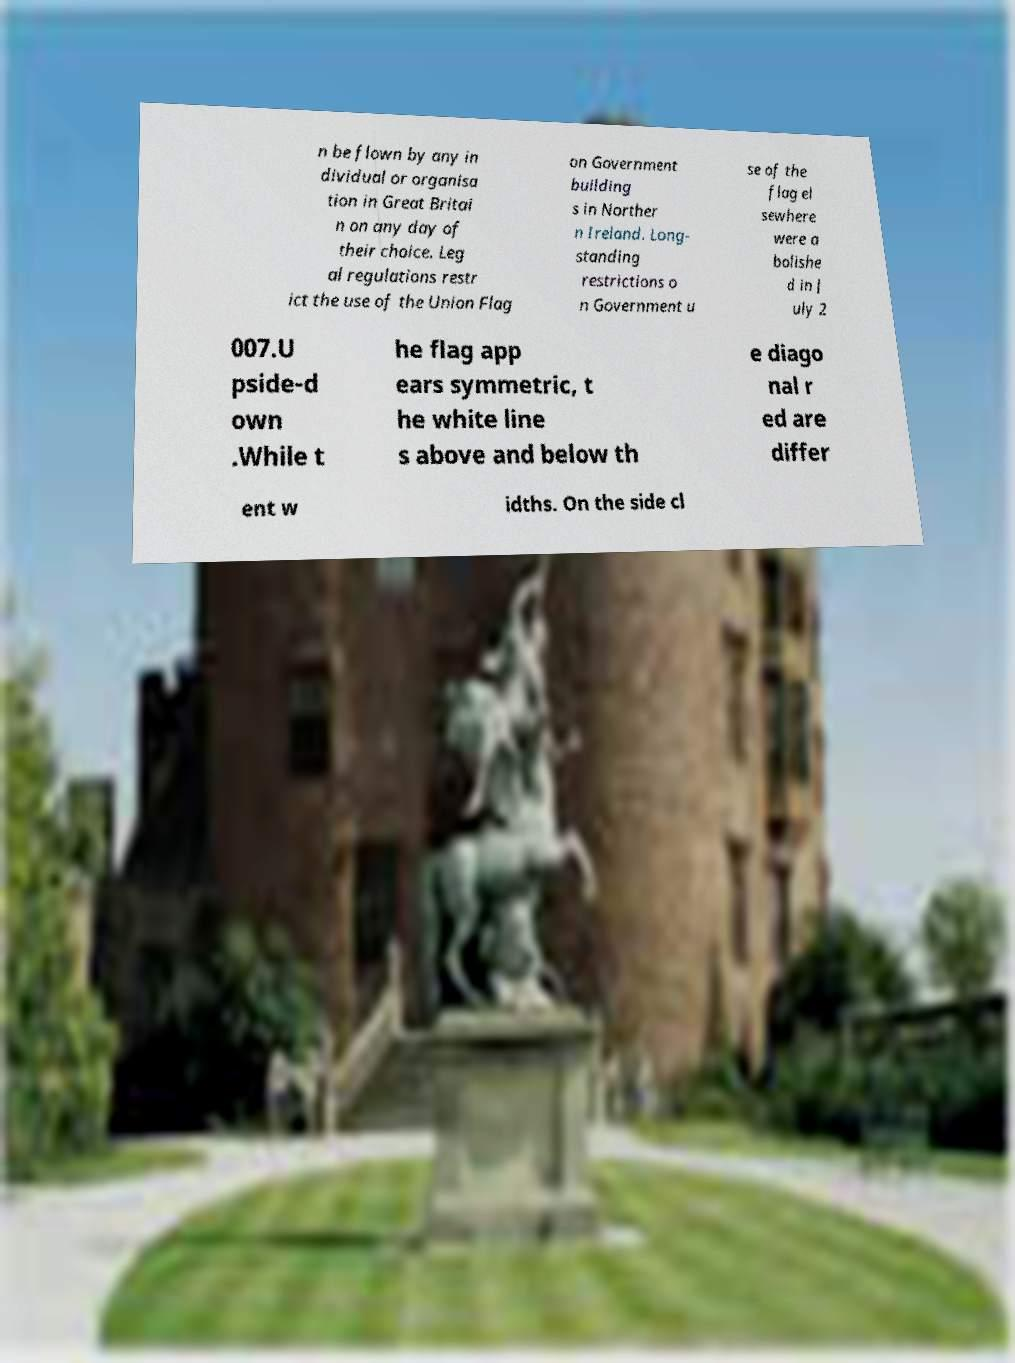There's text embedded in this image that I need extracted. Can you transcribe it verbatim? n be flown by any in dividual or organisa tion in Great Britai n on any day of their choice. Leg al regulations restr ict the use of the Union Flag on Government building s in Norther n Ireland. Long- standing restrictions o n Government u se of the flag el sewhere were a bolishe d in J uly 2 007.U pside-d own .While t he flag app ears symmetric, t he white line s above and below th e diago nal r ed are differ ent w idths. On the side cl 